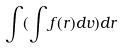Convert formula to latex. <formula><loc_0><loc_0><loc_500><loc_500>\int ( \int f ( r ) d v ) d r</formula> 